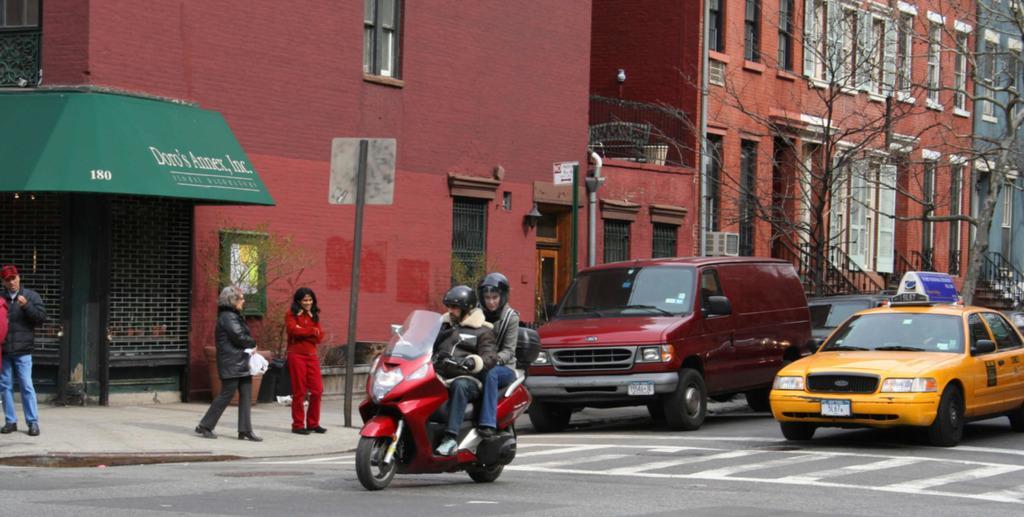In one or two sentences, can you explain what this image depicts? In this image we can see two persons are riding on a bike on the road. In the background we can see few persons, vehicles, plants, trees, buildings, windows, boards on the poles, railings, steps, shutters and other objects. 